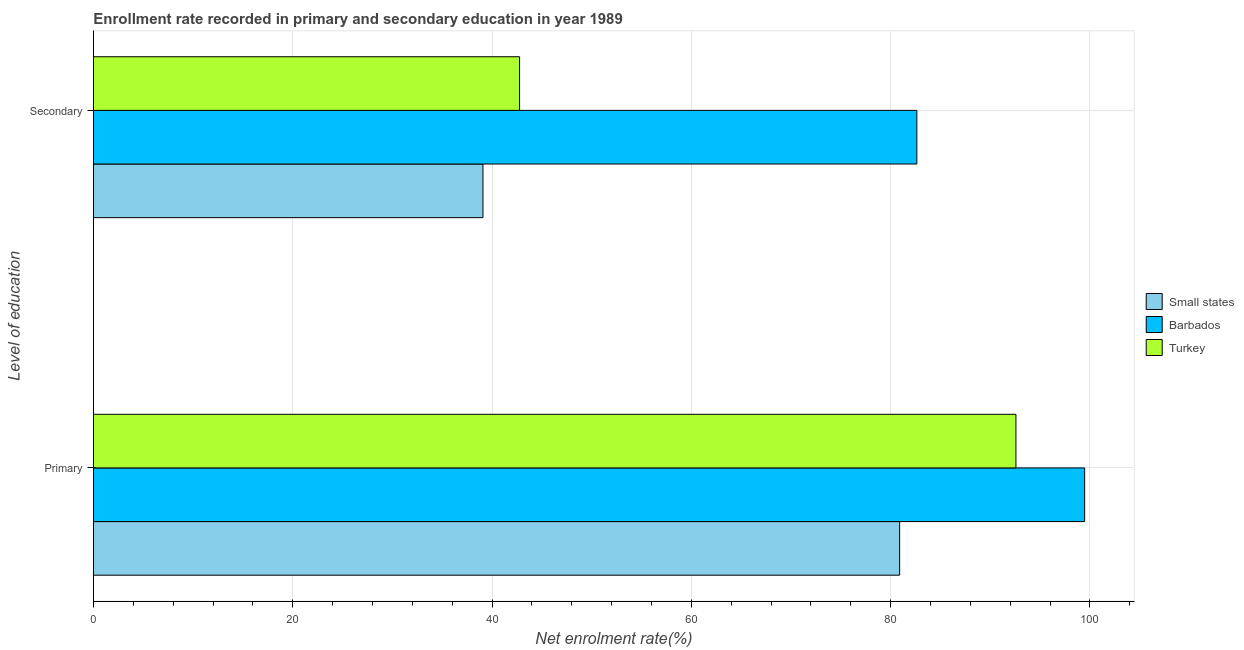How many different coloured bars are there?
Your answer should be compact. 3. How many groups of bars are there?
Keep it short and to the point. 2. Are the number of bars per tick equal to the number of legend labels?
Your answer should be compact. Yes. How many bars are there on the 1st tick from the top?
Ensure brevity in your answer.  3. What is the label of the 2nd group of bars from the top?
Keep it short and to the point. Primary. What is the enrollment rate in secondary education in Turkey?
Your answer should be very brief. 42.76. Across all countries, what is the maximum enrollment rate in secondary education?
Provide a short and direct response. 82.63. Across all countries, what is the minimum enrollment rate in primary education?
Ensure brevity in your answer.  80.91. In which country was the enrollment rate in secondary education maximum?
Your answer should be very brief. Barbados. In which country was the enrollment rate in primary education minimum?
Your answer should be very brief. Small states. What is the total enrollment rate in primary education in the graph?
Offer a terse response. 272.96. What is the difference between the enrollment rate in secondary education in Barbados and that in Small states?
Offer a very short reply. 43.54. What is the difference between the enrollment rate in secondary education in Turkey and the enrollment rate in primary education in Small states?
Give a very brief answer. -38.14. What is the average enrollment rate in secondary education per country?
Ensure brevity in your answer.  54.83. What is the difference between the enrollment rate in primary education and enrollment rate in secondary education in Turkey?
Provide a short and direct response. 49.81. In how many countries, is the enrollment rate in primary education greater than 100 %?
Make the answer very short. 0. What is the ratio of the enrollment rate in secondary education in Turkey to that in Small states?
Make the answer very short. 1.09. In how many countries, is the enrollment rate in secondary education greater than the average enrollment rate in secondary education taken over all countries?
Make the answer very short. 1. What does the 1st bar from the bottom in Secondary represents?
Ensure brevity in your answer.  Small states. How many bars are there?
Keep it short and to the point. 6. How many countries are there in the graph?
Give a very brief answer. 3. Are the values on the major ticks of X-axis written in scientific E-notation?
Make the answer very short. No. Does the graph contain grids?
Your answer should be compact. Yes. Where does the legend appear in the graph?
Make the answer very short. Center right. What is the title of the graph?
Offer a terse response. Enrollment rate recorded in primary and secondary education in year 1989. Does "Nepal" appear as one of the legend labels in the graph?
Ensure brevity in your answer.  No. What is the label or title of the X-axis?
Your answer should be compact. Net enrolment rate(%). What is the label or title of the Y-axis?
Provide a succinct answer. Level of education. What is the Net enrolment rate(%) of Small states in Primary?
Make the answer very short. 80.91. What is the Net enrolment rate(%) in Barbados in Primary?
Provide a succinct answer. 99.47. What is the Net enrolment rate(%) of Turkey in Primary?
Your response must be concise. 92.58. What is the Net enrolment rate(%) of Small states in Secondary?
Your answer should be compact. 39.09. What is the Net enrolment rate(%) in Barbados in Secondary?
Your response must be concise. 82.63. What is the Net enrolment rate(%) in Turkey in Secondary?
Your response must be concise. 42.76. Across all Level of education, what is the maximum Net enrolment rate(%) in Small states?
Your answer should be very brief. 80.91. Across all Level of education, what is the maximum Net enrolment rate(%) in Barbados?
Keep it short and to the point. 99.47. Across all Level of education, what is the maximum Net enrolment rate(%) of Turkey?
Offer a very short reply. 92.58. Across all Level of education, what is the minimum Net enrolment rate(%) of Small states?
Provide a short and direct response. 39.09. Across all Level of education, what is the minimum Net enrolment rate(%) in Barbados?
Offer a terse response. 82.63. Across all Level of education, what is the minimum Net enrolment rate(%) of Turkey?
Your response must be concise. 42.76. What is the total Net enrolment rate(%) of Small states in the graph?
Provide a short and direct response. 119.99. What is the total Net enrolment rate(%) in Barbados in the graph?
Give a very brief answer. 182.1. What is the total Net enrolment rate(%) in Turkey in the graph?
Give a very brief answer. 135.34. What is the difference between the Net enrolment rate(%) of Small states in Primary and that in Secondary?
Your response must be concise. 41.82. What is the difference between the Net enrolment rate(%) in Barbados in Primary and that in Secondary?
Ensure brevity in your answer.  16.84. What is the difference between the Net enrolment rate(%) of Turkey in Primary and that in Secondary?
Make the answer very short. 49.81. What is the difference between the Net enrolment rate(%) in Small states in Primary and the Net enrolment rate(%) in Barbados in Secondary?
Your answer should be compact. -1.73. What is the difference between the Net enrolment rate(%) of Small states in Primary and the Net enrolment rate(%) of Turkey in Secondary?
Your answer should be very brief. 38.14. What is the difference between the Net enrolment rate(%) in Barbados in Primary and the Net enrolment rate(%) in Turkey in Secondary?
Your answer should be very brief. 56.71. What is the average Net enrolment rate(%) of Small states per Level of education?
Ensure brevity in your answer.  60. What is the average Net enrolment rate(%) of Barbados per Level of education?
Ensure brevity in your answer.  91.05. What is the average Net enrolment rate(%) in Turkey per Level of education?
Offer a terse response. 67.67. What is the difference between the Net enrolment rate(%) in Small states and Net enrolment rate(%) in Barbados in Primary?
Give a very brief answer. -18.57. What is the difference between the Net enrolment rate(%) of Small states and Net enrolment rate(%) of Turkey in Primary?
Ensure brevity in your answer.  -11.67. What is the difference between the Net enrolment rate(%) in Barbados and Net enrolment rate(%) in Turkey in Primary?
Give a very brief answer. 6.89. What is the difference between the Net enrolment rate(%) of Small states and Net enrolment rate(%) of Barbados in Secondary?
Offer a terse response. -43.54. What is the difference between the Net enrolment rate(%) in Small states and Net enrolment rate(%) in Turkey in Secondary?
Make the answer very short. -3.67. What is the difference between the Net enrolment rate(%) of Barbados and Net enrolment rate(%) of Turkey in Secondary?
Make the answer very short. 39.87. What is the ratio of the Net enrolment rate(%) in Small states in Primary to that in Secondary?
Your response must be concise. 2.07. What is the ratio of the Net enrolment rate(%) of Barbados in Primary to that in Secondary?
Provide a succinct answer. 1.2. What is the ratio of the Net enrolment rate(%) of Turkey in Primary to that in Secondary?
Provide a short and direct response. 2.16. What is the difference between the highest and the second highest Net enrolment rate(%) of Small states?
Offer a terse response. 41.82. What is the difference between the highest and the second highest Net enrolment rate(%) in Barbados?
Make the answer very short. 16.84. What is the difference between the highest and the second highest Net enrolment rate(%) of Turkey?
Offer a terse response. 49.81. What is the difference between the highest and the lowest Net enrolment rate(%) of Small states?
Offer a very short reply. 41.82. What is the difference between the highest and the lowest Net enrolment rate(%) in Barbados?
Provide a short and direct response. 16.84. What is the difference between the highest and the lowest Net enrolment rate(%) in Turkey?
Ensure brevity in your answer.  49.81. 